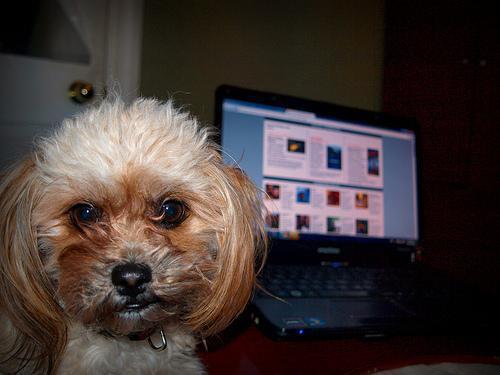How many dogs are there?
Give a very brief answer. 1. 